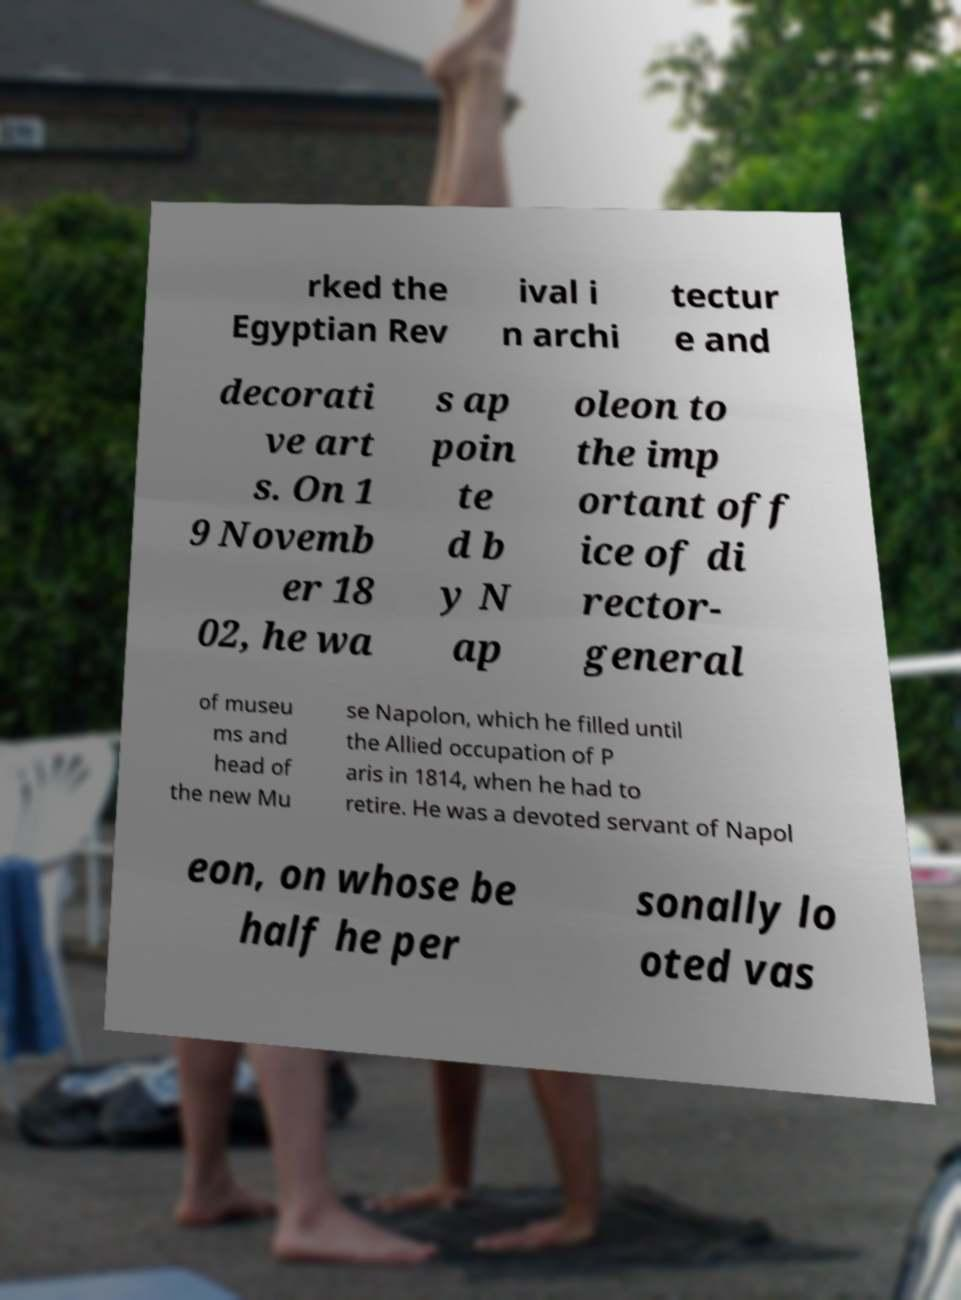Could you assist in decoding the text presented in this image and type it out clearly? rked the Egyptian Rev ival i n archi tectur e and decorati ve art s. On 1 9 Novemb er 18 02, he wa s ap poin te d b y N ap oleon to the imp ortant off ice of di rector- general of museu ms and head of the new Mu se Napolon, which he filled until the Allied occupation of P aris in 1814, when he had to retire. He was a devoted servant of Napol eon, on whose be half he per sonally lo oted vas 